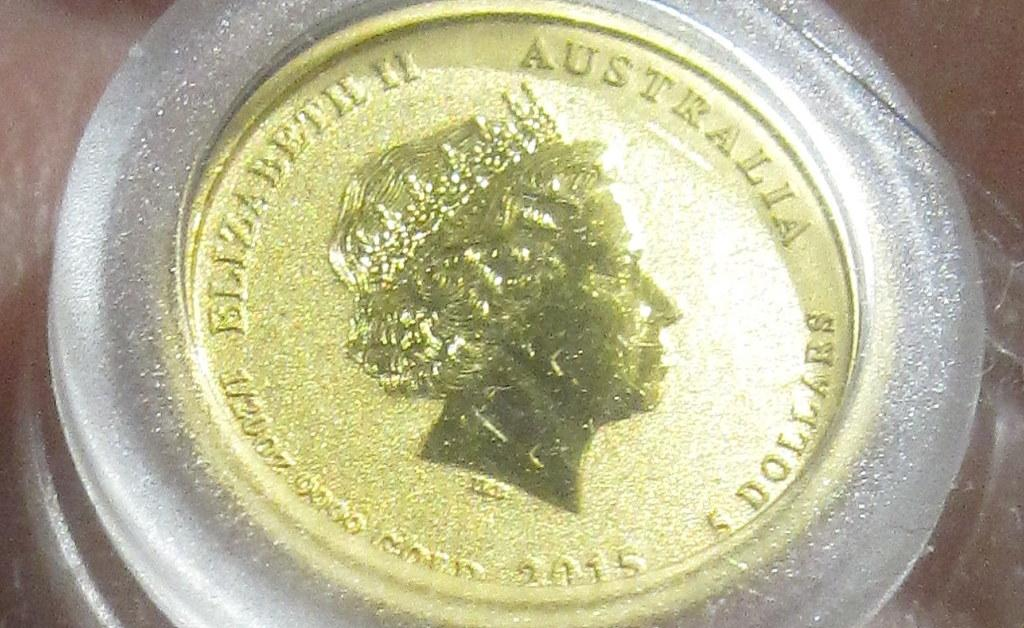Provide a one-sentence caption for the provided image. The coin shown is from the country of Australia. 